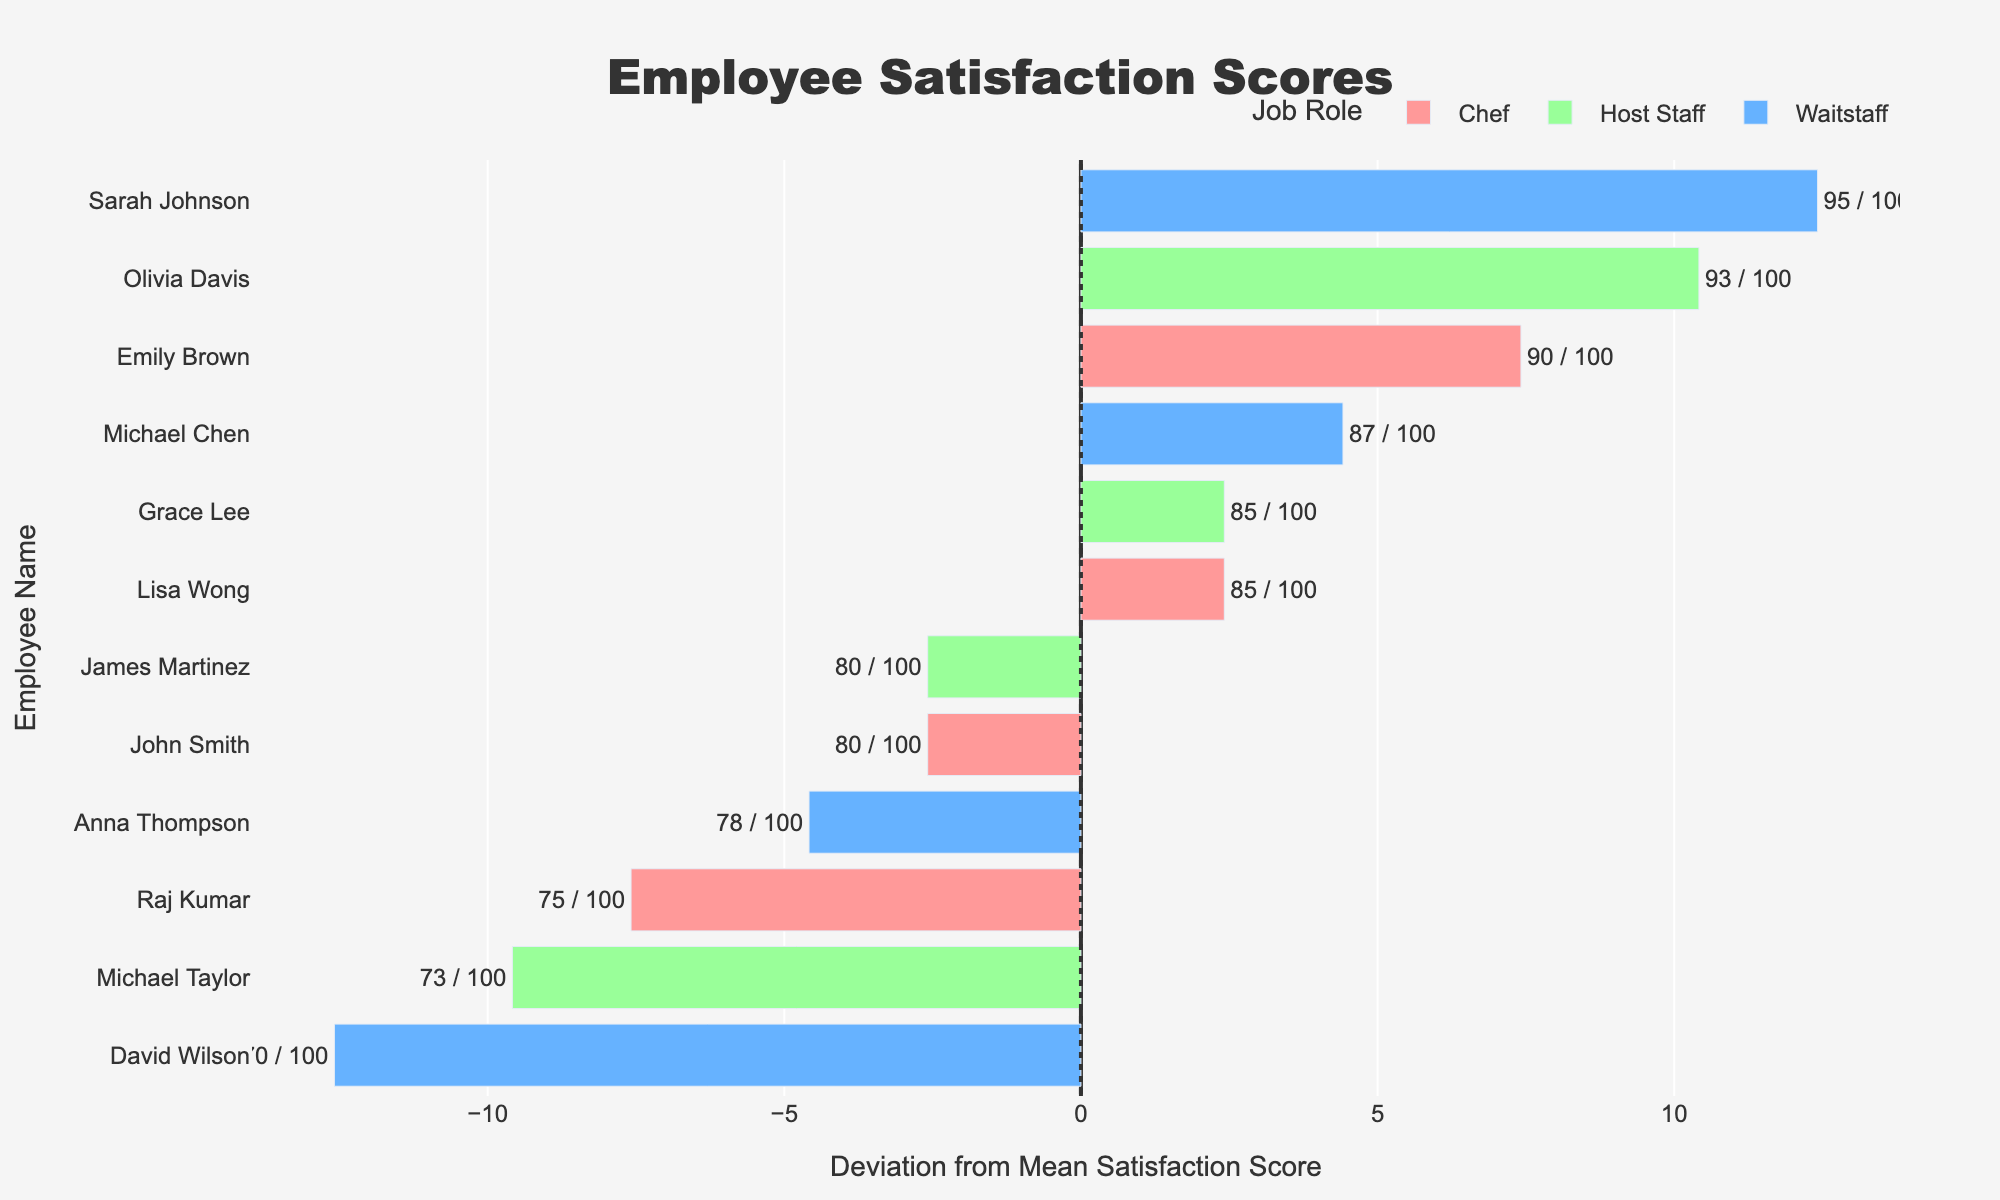Which employee has the highest satisfaction score? The figure shows satisfaction scores for each employee. Sarah Johnson from Waitstaff has the highest score, which is 95.
Answer: Sarah Johnson How many employees have satisfaction scores above the mean? The mean satisfaction score is depicted by the central line at x=0. Counting the bars that exceed this line yields seven employees: Emily Brown, Lisa Wong, Sarah Johnson, Anna Thompson, Michael Chen, Olivia Davis, and Grace Lee.
Answer: Seven Compare the satisfaction scores of the top-scoring Waitstaff and the top-scoring Host Staff. The highest satisfaction score among Waitstaff (Sarah Johnson) is 95, while for Host Staff (Olivia Davis) it is 93. Therefore, Sarah Johnson's score is higher.
Answer: Waitstaff What's the sum of the satisfaction scores for all Waitstaff? Adding the satisfaction scores for each Waitstaff (Sarah Johnson 95, David Wilson 70, Anna Thompson 78, Michael Chen 87) results in 95 + 70 + 78 + 87 = 330.
Answer: 330 Which Chef has the lowest satisfaction score? Among the chefs, Raj Kumar has the lowest satisfaction score of 75.
Answer: Raj Kumar Compare the deviation from the mean satisfaction score for Lisa Wong and Michael Taylor. Lisa Wong is a Chef with a satisfaction score of 85 (deviation +5 from the mean of 80), and Michael Taylor is a Host Staff with a satisfaction score of 73 (deviation -7 from the mean). So, Lisa Wong's score is higher in deviation.
Answer: Lisa Wong What is the mean satisfaction score for the Host Staff? Adding the satisfaction scores for Host Staff (Olivia Davis 93, James Martinez 80, Grace Lee 85, Michael Taylor 73) and dividing by 4 results in (93 + 80 + 85 + 73) / 4 = 82.75.
Answer: 82.75 How does the satisfaction score of James Martinez compare to the top-scoring Chef? James Martinez, a Host Staff, has a satisfaction score of 80, while the top-scoring Chef, Emily Brown, has a score of 90. So, Emily Brown's score is higher.
Answer: James Martinez is lower Which job role has the most employees with above-average satisfaction scores? Counting the number of bars above the mean line for each role: Chef (Emily Brown, Lisa Wong), Waitstaff (Sarah Johnson, Anna Thompson, Michael Chen), and Host Staff (Olivia Davis, Grace Lee). Waitstaff has the most, with three employees.
Answer: Waitstaff 